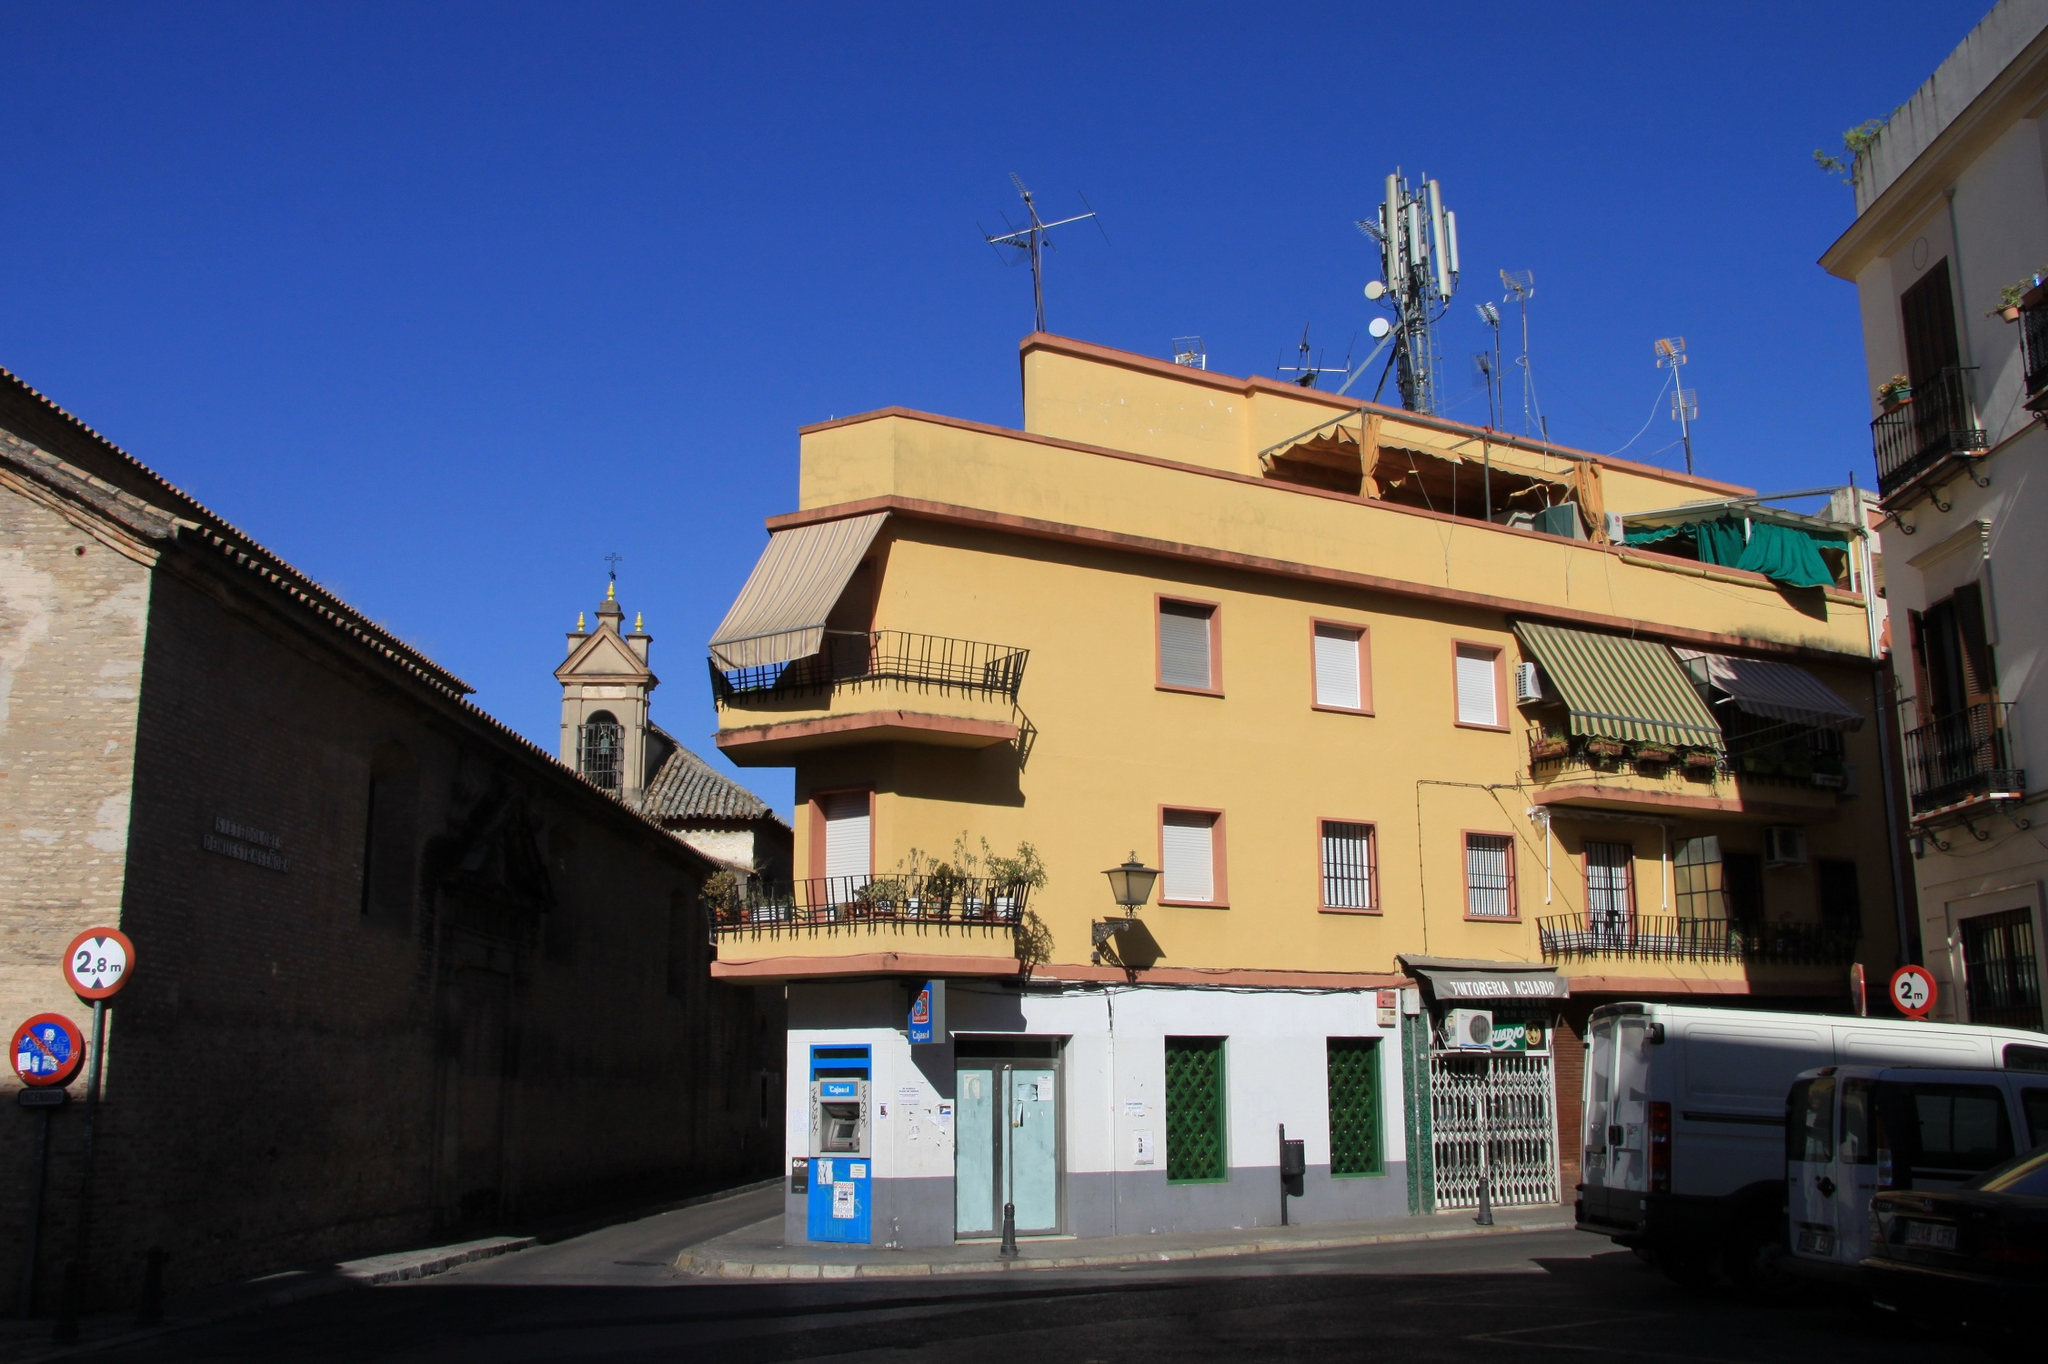Describe a typical day in the life of a resident in the yellow building. A typical day for a resident in the yellow building might start with the hustle and bustle of the morning as they prepare for daily activities. They might enjoy a cup of coffee on one of the balconies, amidst the fresh morning air and the plants that adorn these spaces. As the day progresses, the resident could head out, perhaps catching a bus at the nearby bus stop or using their car parked on the street. The sight and sound of the church bell tolls in the background, adding a rhythmic melody to the day. By late afternoon, the warm sunlight illuminates the building's facade, creating a cozy ambiance. The day might wind down with a casual stroll to a local market or a nearby park. As evening falls, they return to their home, the yellow walls now glowing softly in the twilight, a comforting sight that signals the end of another day in this charming European city. 